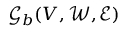<formula> <loc_0><loc_0><loc_500><loc_500>\mathcal { G } _ { b } ( V , \mathcal { W } , \mathcal { E } )</formula> 